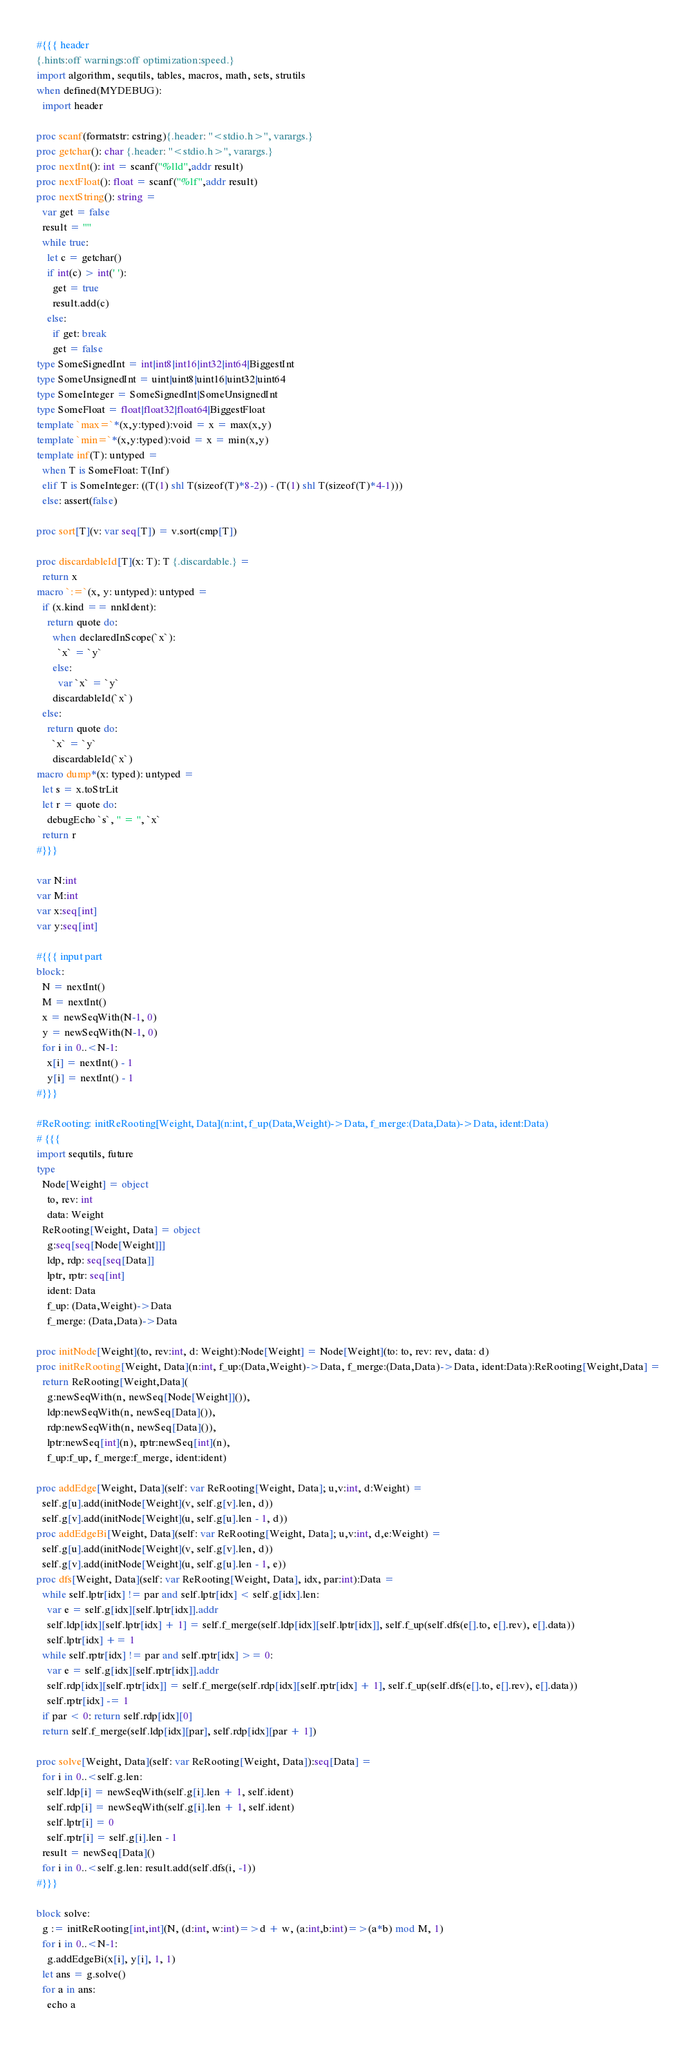<code> <loc_0><loc_0><loc_500><loc_500><_Nim_>#{{{ header
{.hints:off warnings:off optimization:speed.}
import algorithm, sequtils, tables, macros, math, sets, strutils
when defined(MYDEBUG):
  import header

proc scanf(formatstr: cstring){.header: "<stdio.h>", varargs.}
proc getchar(): char {.header: "<stdio.h>", varargs.}
proc nextInt(): int = scanf("%lld",addr result)
proc nextFloat(): float = scanf("%lf",addr result)
proc nextString(): string =
  var get = false
  result = ""
  while true:
    let c = getchar()
    if int(c) > int(' '):
      get = true
      result.add(c)
    else:
      if get: break
      get = false
type SomeSignedInt = int|int8|int16|int32|int64|BiggestInt
type SomeUnsignedInt = uint|uint8|uint16|uint32|uint64
type SomeInteger = SomeSignedInt|SomeUnsignedInt
type SomeFloat = float|float32|float64|BiggestFloat
template `max=`*(x,y:typed):void = x = max(x,y)
template `min=`*(x,y:typed):void = x = min(x,y)
template inf(T): untyped = 
  when T is SomeFloat: T(Inf)
  elif T is SomeInteger: ((T(1) shl T(sizeof(T)*8-2)) - (T(1) shl T(sizeof(T)*4-1)))
  else: assert(false)

proc sort[T](v: var seq[T]) = v.sort(cmp[T])

proc discardableId[T](x: T): T {.discardable.} =
  return x
macro `:=`(x, y: untyped): untyped =
  if (x.kind == nnkIdent):
    return quote do:
      when declaredInScope(`x`):
        `x` = `y`
      else:
        var `x` = `y`
      discardableId(`x`)
  else:
    return quote do:
      `x` = `y`
      discardableId(`x`)
macro dump*(x: typed): untyped =
  let s = x.toStrLit
  let r = quote do:
    debugEcho `s`, " = ", `x`
  return r
#}}}

var N:int
var M:int
var x:seq[int]
var y:seq[int]

#{{{ input part
block:
  N = nextInt()
  M = nextInt()
  x = newSeqWith(N-1, 0)
  y = newSeqWith(N-1, 0)
  for i in 0..<N-1:
    x[i] = nextInt() - 1
    y[i] = nextInt() - 1
#}}}

#ReRooting: initReRooting[Weight, Data](n:int, f_up(Data,Weight)->Data, f_merge:(Data,Data)->Data, ident:Data)
# {{{
import sequtils, future
type
  Node[Weight] = object
    to, rev: int
    data: Weight
  ReRooting[Weight, Data] = object
    g:seq[seq[Node[Weight]]]
    ldp, rdp: seq[seq[Data]]
    lptr, rptr: seq[int]
    ident: Data
    f_up: (Data,Weight)->Data
    f_merge: (Data,Data)->Data

proc initNode[Weight](to, rev:int, d: Weight):Node[Weight] = Node[Weight](to: to, rev: rev, data: d)
proc initReRooting[Weight, Data](n:int, f_up:(Data,Weight)->Data, f_merge:(Data,Data)->Data, ident:Data):ReRooting[Weight,Data] =
  return ReRooting[Weight,Data](
    g:newSeqWith(n, newSeq[Node[Weight]]()),
    ldp:newSeqWith(n, newSeq[Data]()),
    rdp:newSeqWith(n, newSeq[Data]()),
    lptr:newSeq[int](n), rptr:newSeq[int](n),
    f_up:f_up, f_merge:f_merge, ident:ident)

proc addEdge[Weight, Data](self: var ReRooting[Weight, Data]; u,v:int, d:Weight) =
  self.g[u].add(initNode[Weight](v, self.g[v].len, d))
  self.g[v].add(initNode[Weight](u, self.g[u].len - 1, d))
proc addEdgeBi[Weight, Data](self: var ReRooting[Weight, Data]; u,v:int, d,e:Weight) =
  self.g[u].add(initNode[Weight](v, self.g[v].len, d))
  self.g[v].add(initNode[Weight](u, self.g[u].len - 1, e))
proc dfs[Weight, Data](self: var ReRooting[Weight, Data], idx, par:int):Data =
  while self.lptr[idx] != par and self.lptr[idx] < self.g[idx].len:
    var e = self.g[idx][self.lptr[idx]].addr
    self.ldp[idx][self.lptr[idx] + 1] = self.f_merge(self.ldp[idx][self.lptr[idx]], self.f_up(self.dfs(e[].to, e[].rev), e[].data))
    self.lptr[idx] += 1
  while self.rptr[idx] != par and self.rptr[idx] >= 0:
    var e = self.g[idx][self.rptr[idx]].addr
    self.rdp[idx][self.rptr[idx]] = self.f_merge(self.rdp[idx][self.rptr[idx] + 1], self.f_up(self.dfs(e[].to, e[].rev), e[].data))
    self.rptr[idx] -= 1
  if par < 0: return self.rdp[idx][0]
  return self.f_merge(self.ldp[idx][par], self.rdp[idx][par + 1])

proc solve[Weight, Data](self: var ReRooting[Weight, Data]):seq[Data] =
  for i in 0..<self.g.len:
    self.ldp[i] = newSeqWith(self.g[i].len + 1, self.ident)
    self.rdp[i] = newSeqWith(self.g[i].len + 1, self.ident)
    self.lptr[i] = 0
    self.rptr[i] = self.g[i].len - 1
  result = newSeq[Data]()
  for i in 0..<self.g.len: result.add(self.dfs(i, -1))
#}}}

block solve:
  g := initReRooting[int,int](N, (d:int, w:int)=>d + w, (a:int,b:int)=>(a*b) mod M, 1)
  for i in 0..<N-1:
    g.addEdgeBi(x[i], y[i], 1, 1)
  let ans = g.solve()
  for a in ans:
    echo a
</code> 